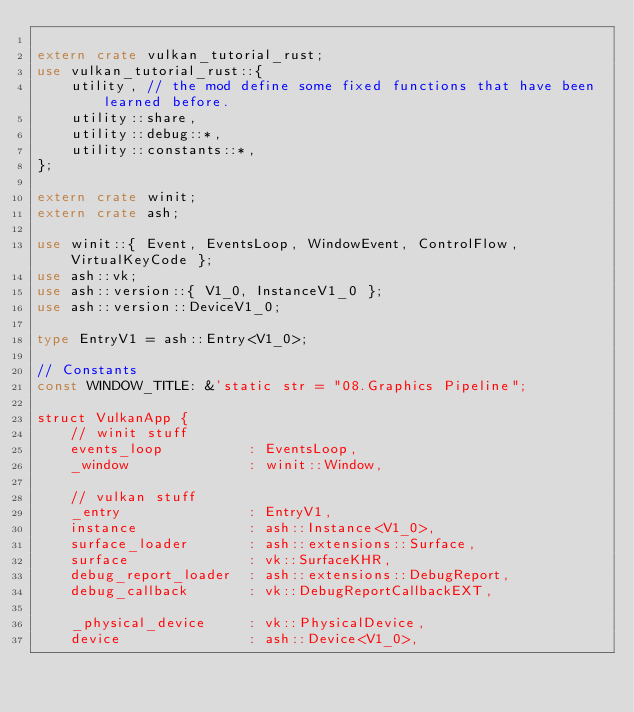Convert code to text. <code><loc_0><loc_0><loc_500><loc_500><_Rust_>
extern crate vulkan_tutorial_rust;
use vulkan_tutorial_rust::{
    utility, // the mod define some fixed functions that have been learned before.
    utility::share,
    utility::debug::*,
    utility::constants::*,
};

extern crate winit;
extern crate ash;

use winit::{ Event, EventsLoop, WindowEvent, ControlFlow, VirtualKeyCode };
use ash::vk;
use ash::version::{ V1_0, InstanceV1_0 };
use ash::version::DeviceV1_0;

type EntryV1 = ash::Entry<V1_0>;

// Constants
const WINDOW_TITLE: &'static str = "08.Graphics Pipeline";

struct VulkanApp {
    // winit stuff
    events_loop          : EventsLoop,
    _window              : winit::Window,

    // vulkan stuff
    _entry               : EntryV1,
    instance             : ash::Instance<V1_0>,
    surface_loader       : ash::extensions::Surface,
    surface              : vk::SurfaceKHR,
    debug_report_loader  : ash::extensions::DebugReport,
    debug_callback       : vk::DebugReportCallbackEXT,

    _physical_device     : vk::PhysicalDevice,
    device               : ash::Device<V1_0>,
</code> 